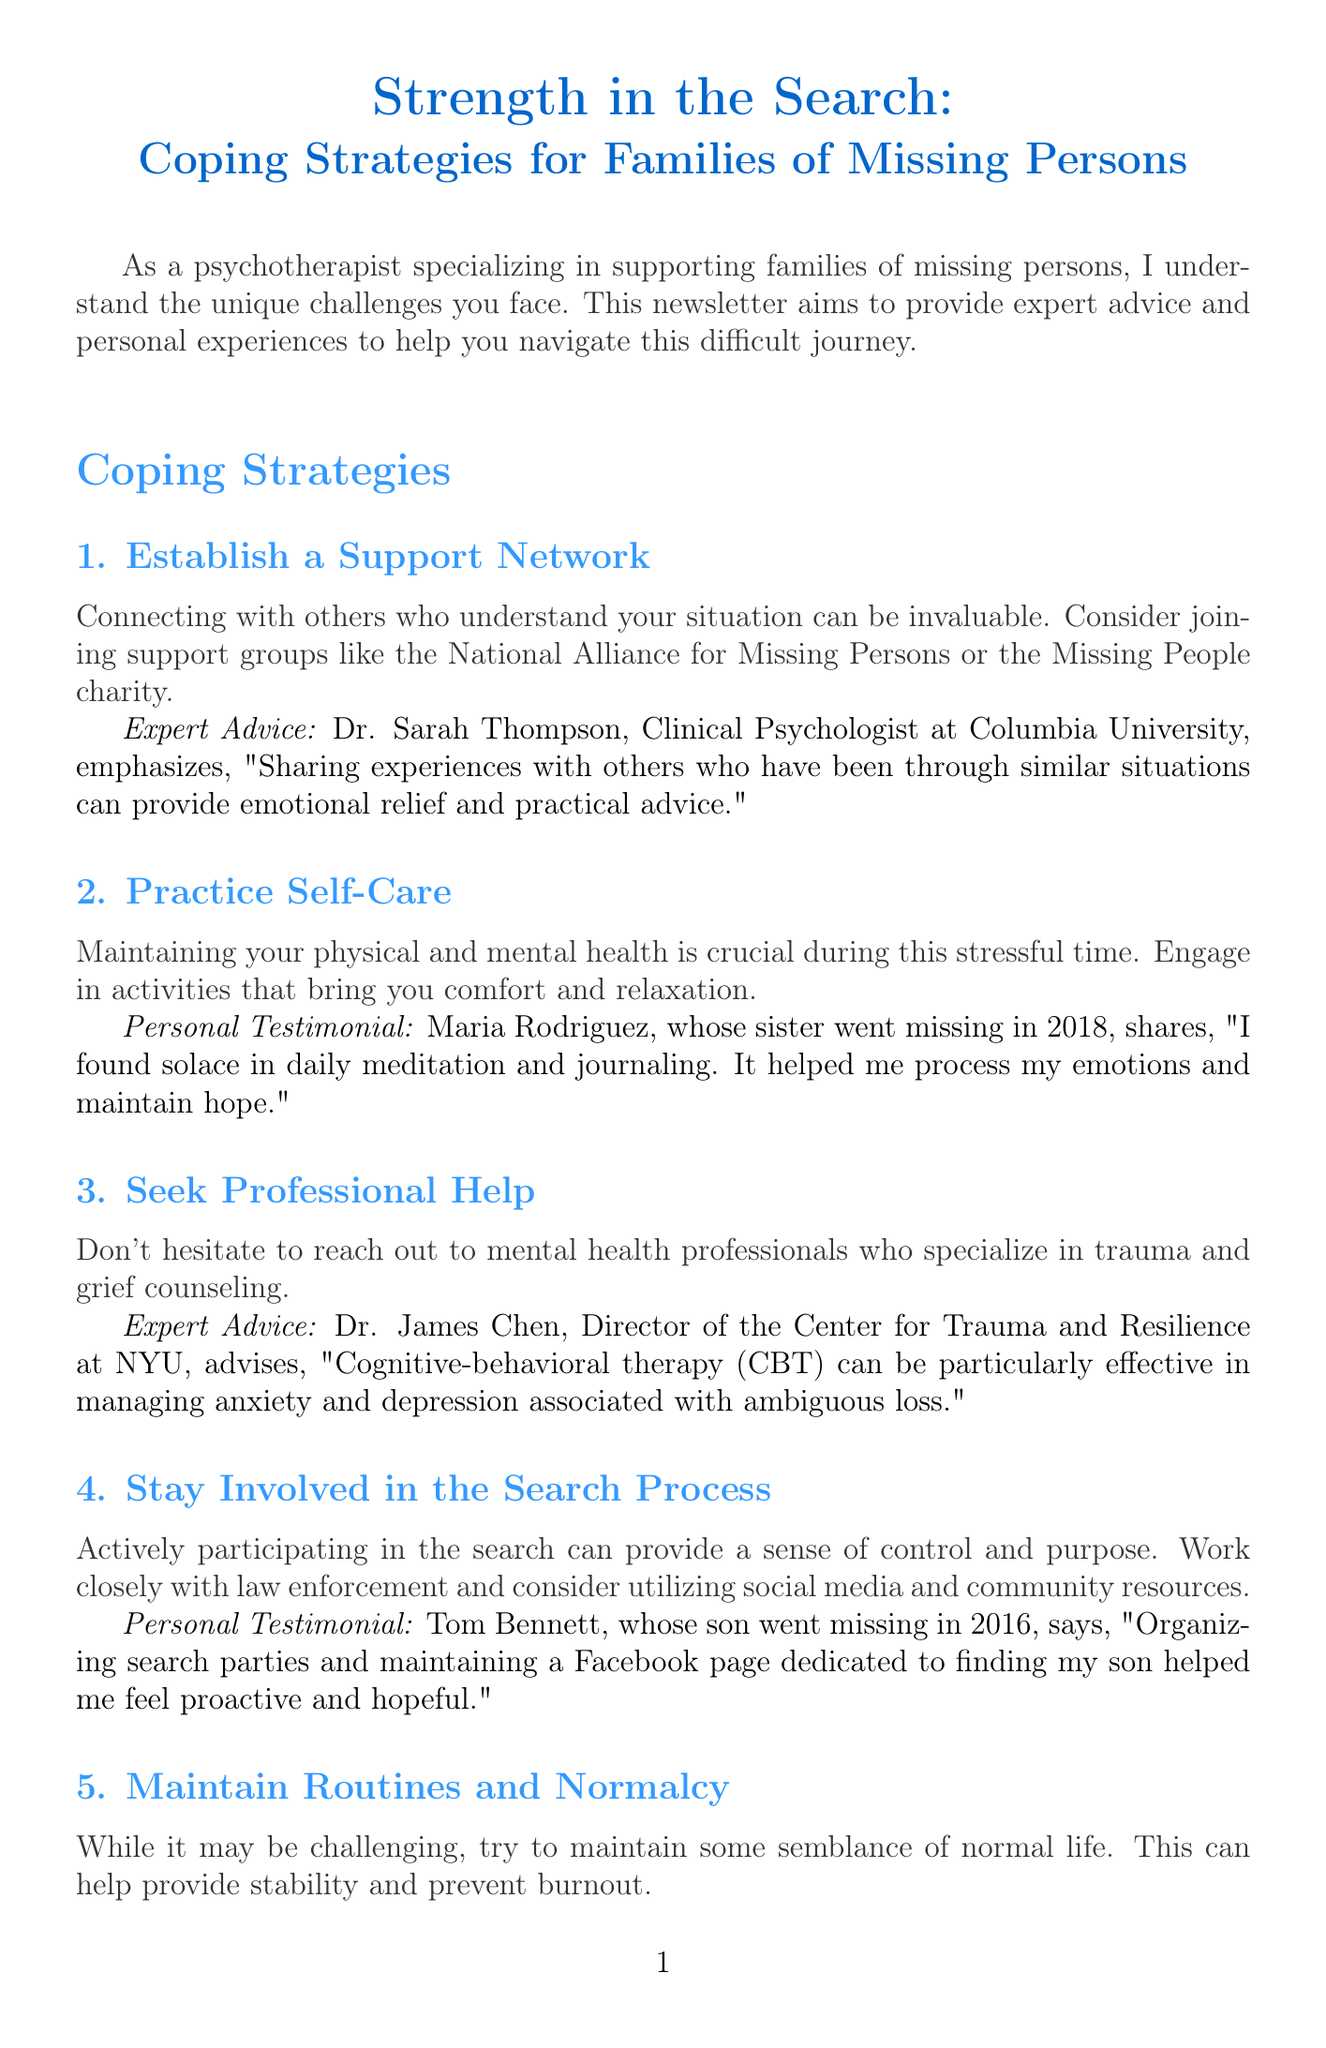What is the title of the newsletter? The title is stated at the beginning of the document, providing the main theme of the newsletter.
Answer: Strength in the Search: Coping Strategies for Families of Missing Persons Who is the expert quoted for establishing a support network? The document mentions Dr. Sarah Thompson in the context of sharing experiences in support networks.
Answer: Dr. Sarah Thompson What year did Maria Rodriguez's sister go missing? The document provides a specific year related to Maria Rodriguez's personal experience.
Answer: 2018 What type of therapy is recommended by Dr. James Chen? The document provides information on the specific type of therapy that Dr. James Chen advises for managing anxiety and depression.
Answer: Cognitive-behavioral therapy (CBT) Which resource offers support for families of missing children? The resource section names a specific organization that supports families dealing with missing children.
Answer: National Center for Missing and Exploited Children What activity helped Tom Bennett feel proactive during the search? The document shares a personal testament from Tom Bennett regarding an activity that contributed to his sense of agency.
Answer: Organizing search parties What is suggested to create stability during the search process? The document discusses an aspect of maintaining life that can provide a sense of stability during difficult times.
Answer: Maintain routines and normalcy Who is recommended to seek help from concerning trauma and grief? The document emphasizes a type of professional that families should reach out to during their search.
Answer: Mental health professionals What mobile app is mentioned for managing PTSD symptoms? The resource section lists a specific mobile application designed to assist with PTSD symptoms.
Answer: PTSD Coach 